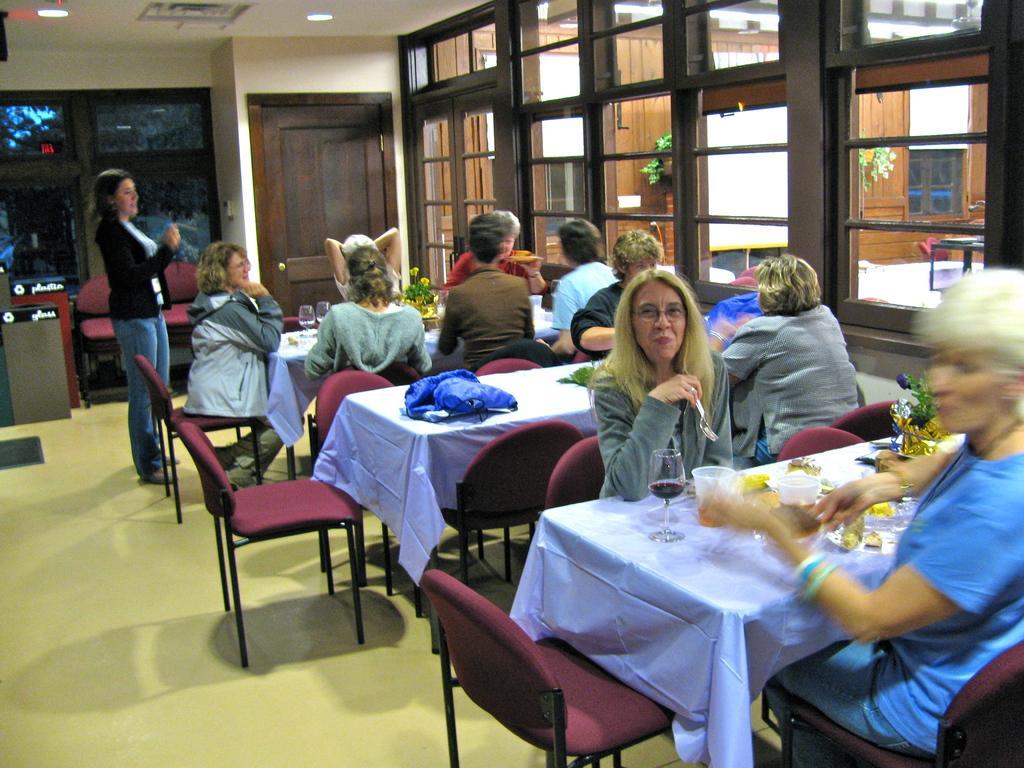How would you summarize this image in a sentence or two? The picture is taken in a closed room where there are number of people sitting on the chairs in front of the tables. On the table there are glasses,foods and plates and some plants and on the left corner of the picture one woman is standing wearing the black jacket and blue jeans, behind her there are chairs and big glass windows and wooden door and behind the people there are big windows and outside of the windows there is a room with open space and some plants in it. 